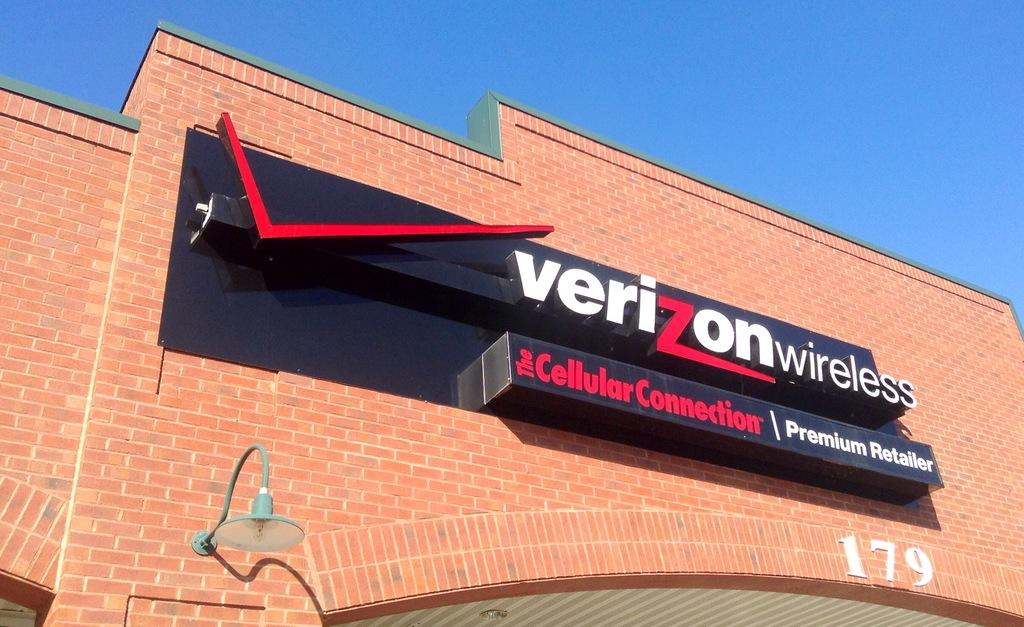<image>
Offer a succinct explanation of the picture presented. The street number of this building is 179. 